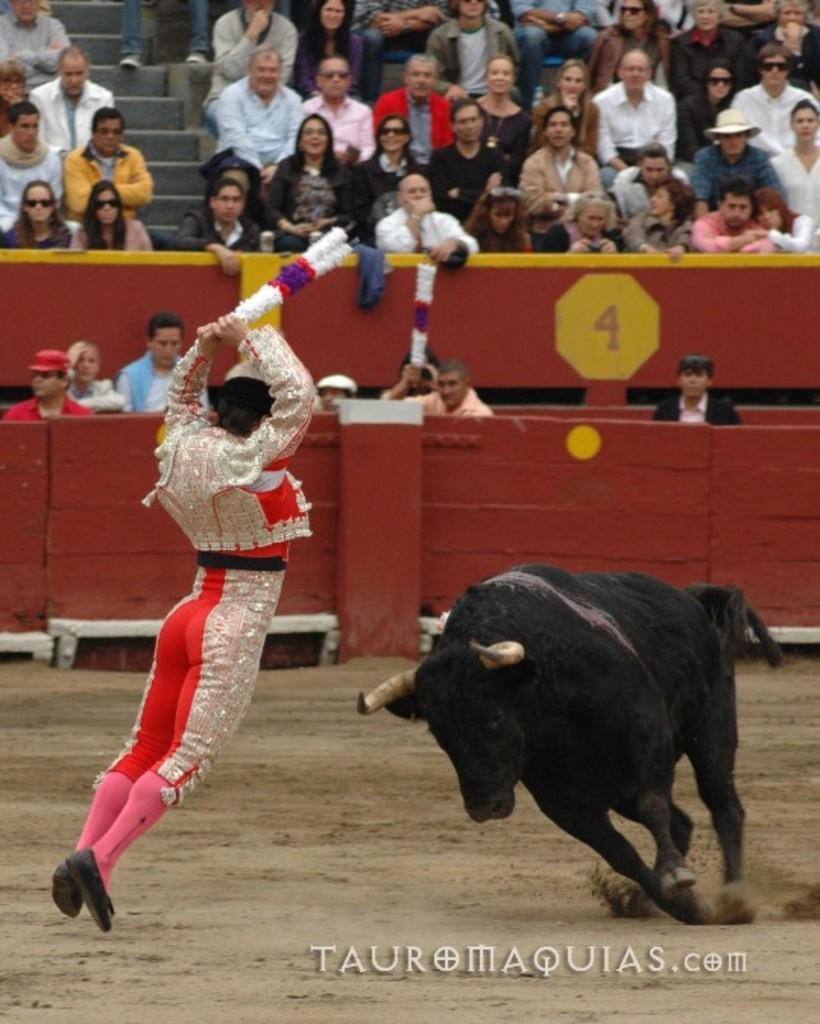In one or two sentences, can you explain what this image depicts? In this image, at the right side there is a black color bull and we can see a person, in the background there are some people sitting and they are watching the bull. 